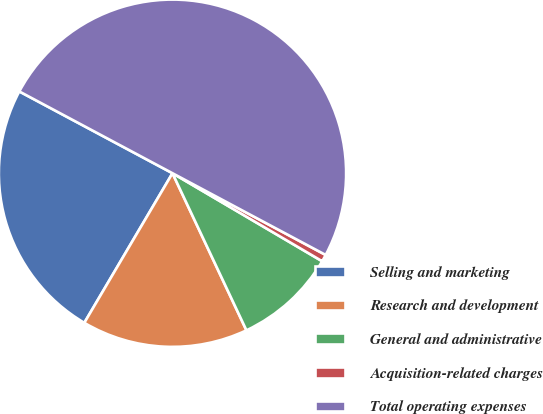Convert chart to OTSL. <chart><loc_0><loc_0><loc_500><loc_500><pie_chart><fcel>Selling and marketing<fcel>Research and development<fcel>General and administrative<fcel>Acquisition-related charges<fcel>Total operating expenses<nl><fcel>24.33%<fcel>15.48%<fcel>9.54%<fcel>0.66%<fcel>50.0%<nl></chart> 